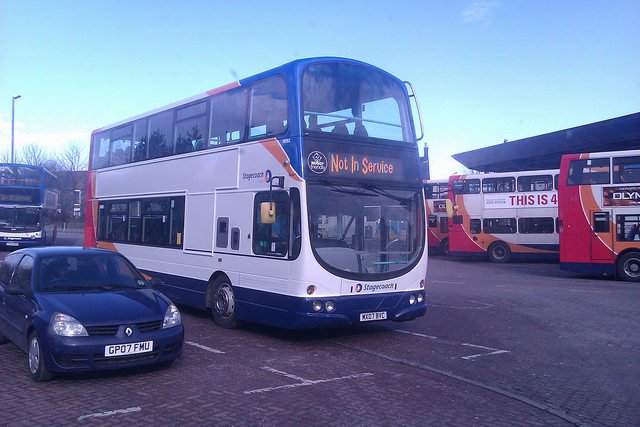<image>What time of year is this picture taken? It is unknown what time of year this picture was taken. It could possibly be fall or winter. What time of year is this picture taken? It is ambiguous what time of year the picture is taken. It can be seen in fall or winter. 